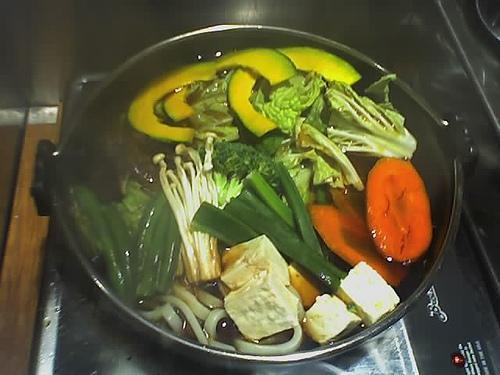What are the white blocks in the soup called?
Select the accurate answer and provide explanation: 'Answer: answer
Rationale: rationale.'
Options: Mozzarella cheese, cabbage, turnip, tofu. Answer: tofu.
Rationale: A food with this texture that is prepared in squares like those visible is likely to be answer a. 